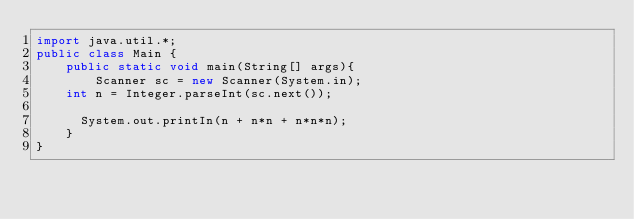<code> <loc_0><loc_0><loc_500><loc_500><_Java_>import java.util.*;
public class Main {
    public static void main(String[] args){
        Scanner sc = new Scanner(System.in);
		int n = Integer.parseInt(sc.next());
      
     	System.out.printIn(n + n*n + n*n*n);
    }
}</code> 